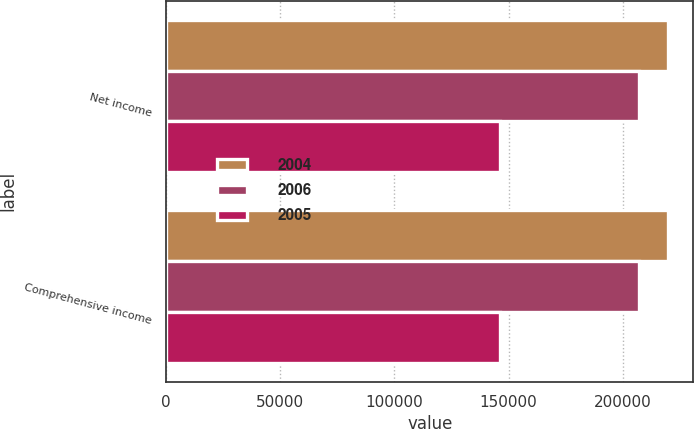<chart> <loc_0><loc_0><loc_500><loc_500><stacked_bar_chart><ecel><fcel>Net income<fcel>Comprehensive income<nl><fcel>2004<fcel>219952<fcel>219804<nl><fcel>2006<fcel>207311<fcel>207311<nl><fcel>2005<fcel>146256<fcel>146256<nl></chart> 